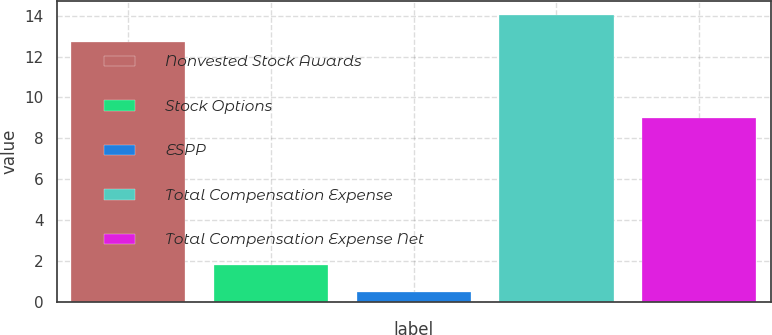Convert chart to OTSL. <chart><loc_0><loc_0><loc_500><loc_500><bar_chart><fcel>Nonvested Stock Awards<fcel>Stock Options<fcel>ESPP<fcel>Total Compensation Expense<fcel>Total Compensation Expense Net<nl><fcel>12.7<fcel>1.83<fcel>0.5<fcel>14.03<fcel>9<nl></chart> 